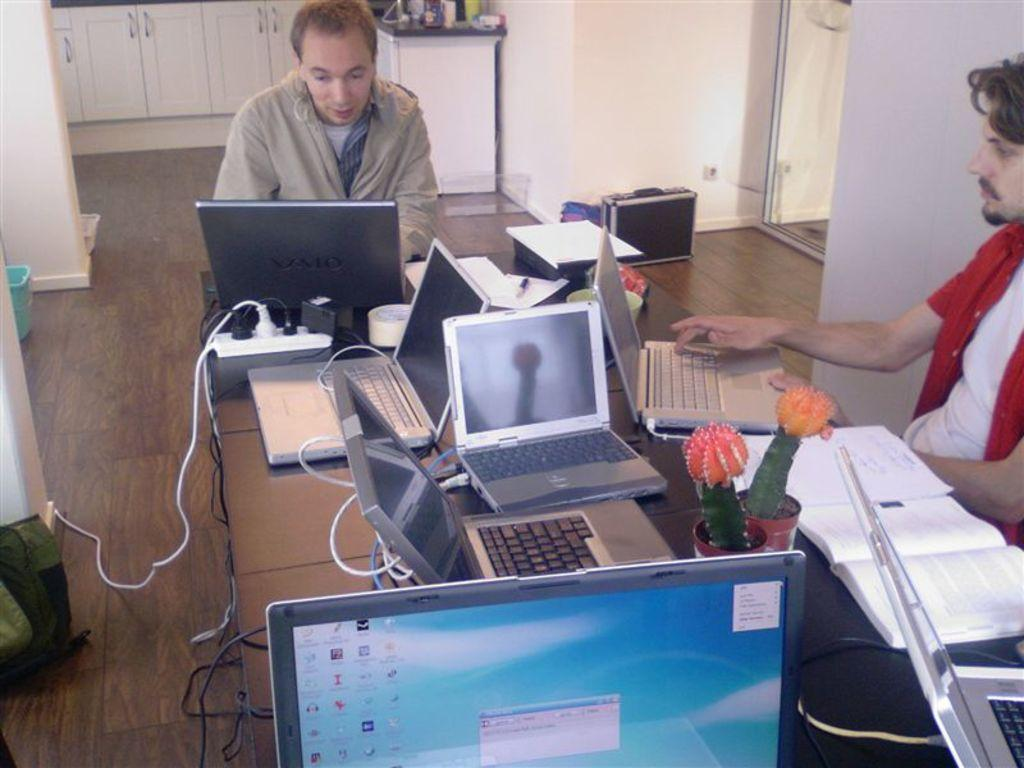<image>
Render a clear and concise summary of the photo. Two men working at a desk and the computer in the foreground has an error message on it. 